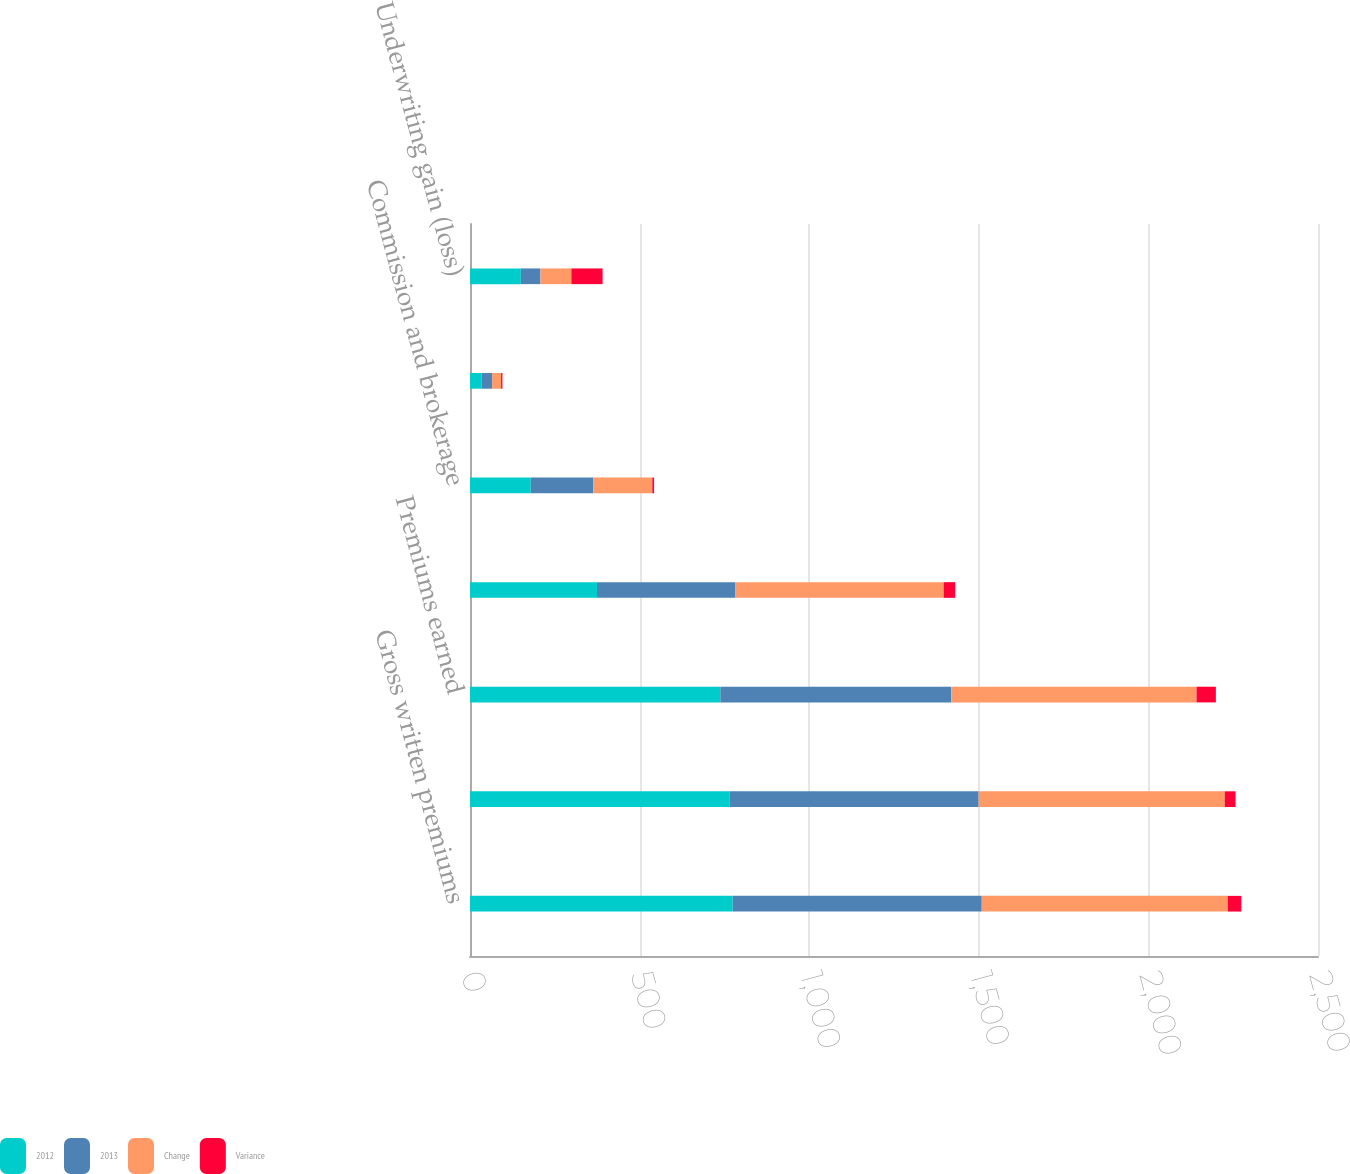<chart> <loc_0><loc_0><loc_500><loc_500><stacked_bar_chart><ecel><fcel>Gross written premiums<fcel>Net written premiums<fcel>Premiums earned<fcel>Incurred losses and LAE<fcel>Commission and brokerage<fcel>Other underwriting expenses<fcel>Underwriting gain (loss)<nl><fcel>2012<fcel>774.3<fcel>765.7<fcel>738<fcel>374.4<fcel>179.1<fcel>34.7<fcel>149.8<nl><fcel>2013<fcel>734.4<fcel>733.8<fcel>680.9<fcel>408.2<fcel>184.4<fcel>30.6<fcel>57.8<nl><fcel>Change<fcel>725.3<fcel>725.5<fcel>723<fcel>613.9<fcel>174<fcel>26.3<fcel>91.2<nl><fcel>Variance<fcel>39.9<fcel>31.9<fcel>57<fcel>33.9<fcel>5.2<fcel>4<fcel>92.1<nl></chart> 